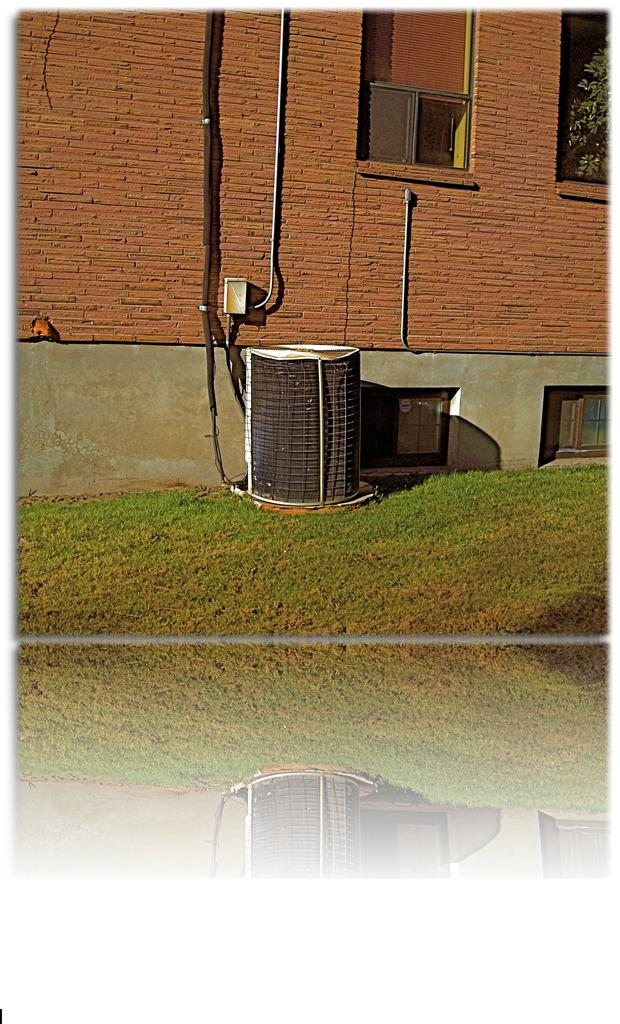What type of vegetation is visible in the image? There is grass in the image. What architectural features can be seen in the image? There are windows and a wall in the image. What natural elements are present in the image? There are leaves in the image. Can you describe the unspecified objects in the image? Unfortunately, the facts provided do not specify the nature of the unspecified objects. Can you hear the clam laughing in the image? There is no clam or laughter present in the image. Is there any sleet visible in the image? The facts provided do not mention any sleet in the image. 